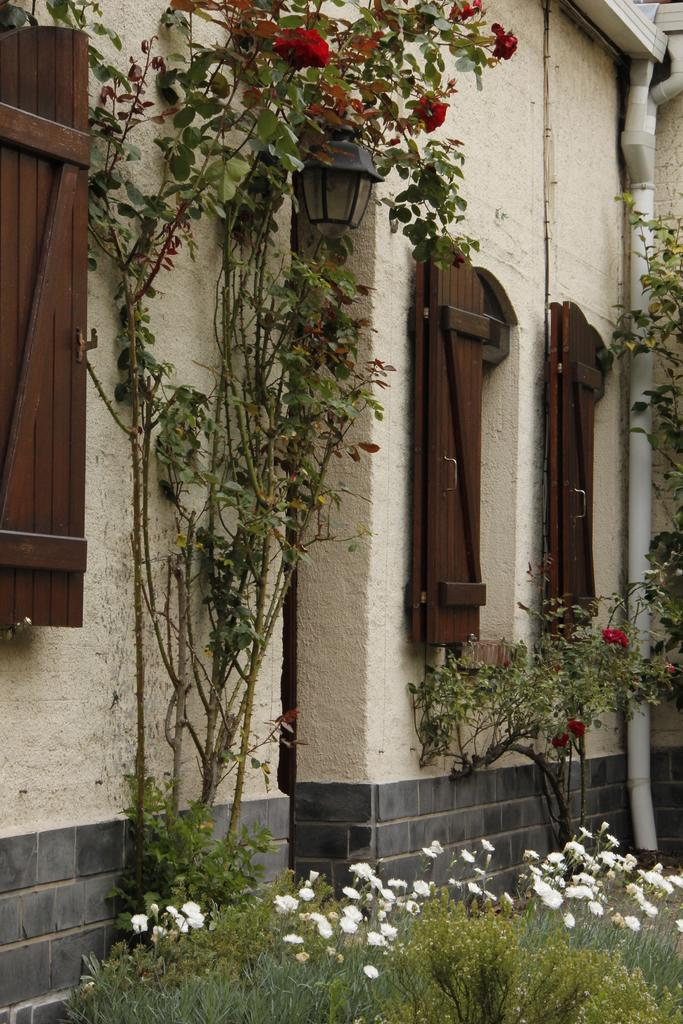Where was the image taken? The image was clicked outside. What is the main subject in the middle of the image? There is a building in the middle of the image. What type of vegetation is present at the bottom of the image? There are plants at the bottom of the image. Are there any flowers associated with the plants? Yes, there are flowers associated with the plants. What color are the horses in the image? There are no horses present in the image. 